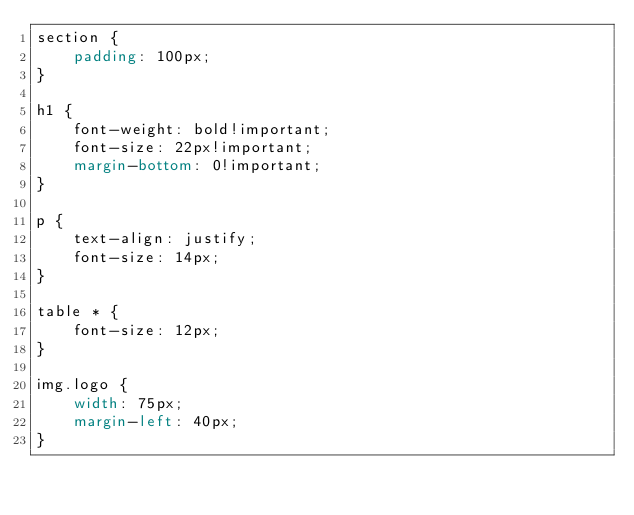Convert code to text. <code><loc_0><loc_0><loc_500><loc_500><_CSS_>section {
    padding: 100px;
}

h1 {
    font-weight: bold!important;
    font-size: 22px!important;
    margin-bottom: 0!important;
}

p {
    text-align: justify;
    font-size: 14px;
}

table * {
    font-size: 12px;    
}

img.logo {
    width: 75px;
    margin-left: 40px;
}</code> 